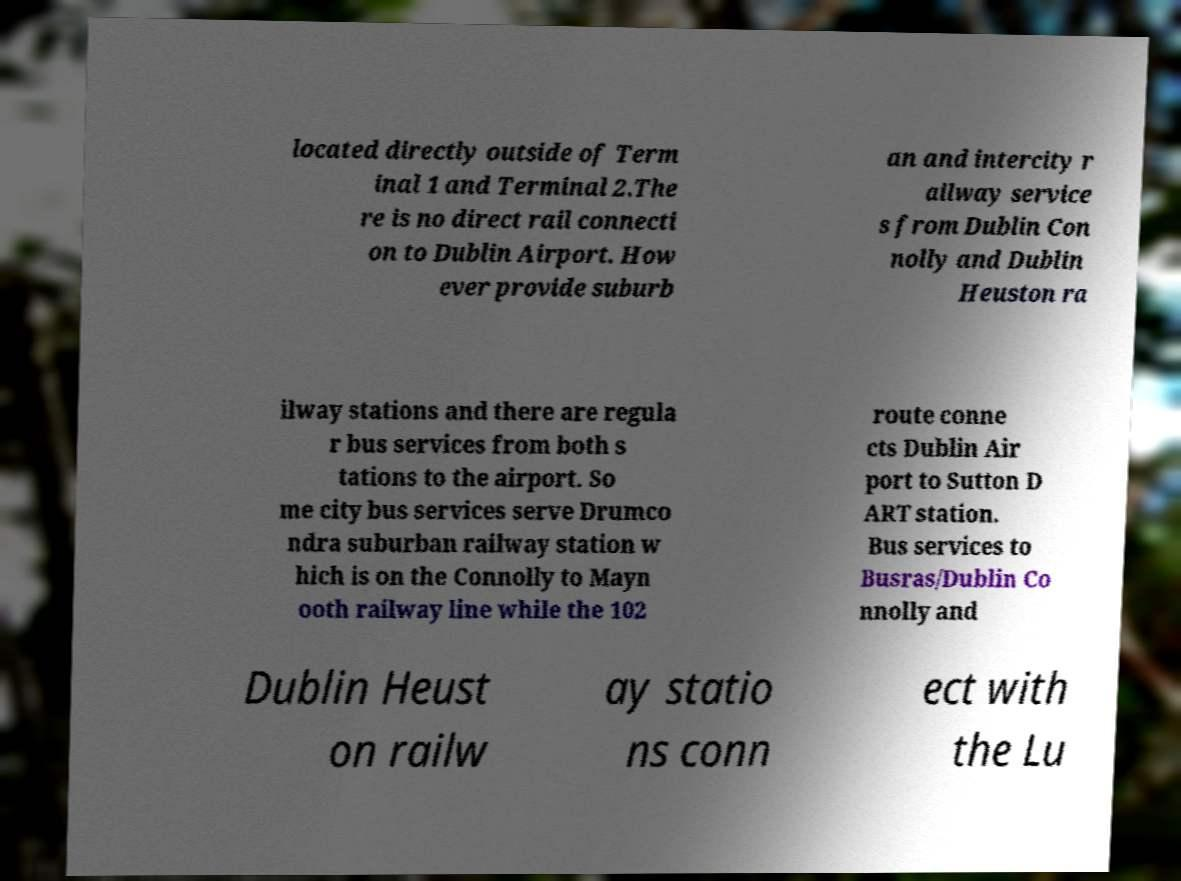Please read and relay the text visible in this image. What does it say? located directly outside of Term inal 1 and Terminal 2.The re is no direct rail connecti on to Dublin Airport. How ever provide suburb an and intercity r ailway service s from Dublin Con nolly and Dublin Heuston ra ilway stations and there are regula r bus services from both s tations to the airport. So me city bus services serve Drumco ndra suburban railway station w hich is on the Connolly to Mayn ooth railway line while the 102 route conne cts Dublin Air port to Sutton D ART station. Bus services to Busras/Dublin Co nnolly and Dublin Heust on railw ay statio ns conn ect with the Lu 